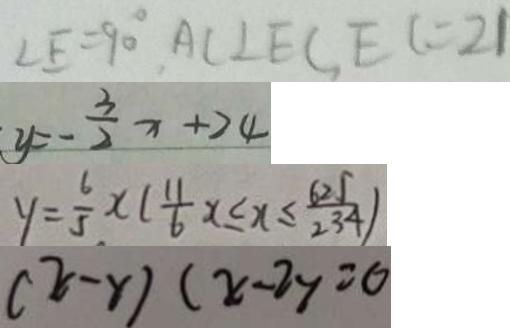Convert formula to latex. <formula><loc_0><loc_0><loc_500><loc_500>\angle E = 9 0 ^ { \circ } , A C \bot E C , E C = 2 1 
 y = - \frac { 3 } { 2 } x + 2 4 
 y = \frac { 6 } { 5 } x ( \frac { 1 1 } { 6 } x \leq x \leq \frac { 6 2 5 } { 2 3 4 } ) 
 ( x - y ) ( x - 2 y = 0</formula> 